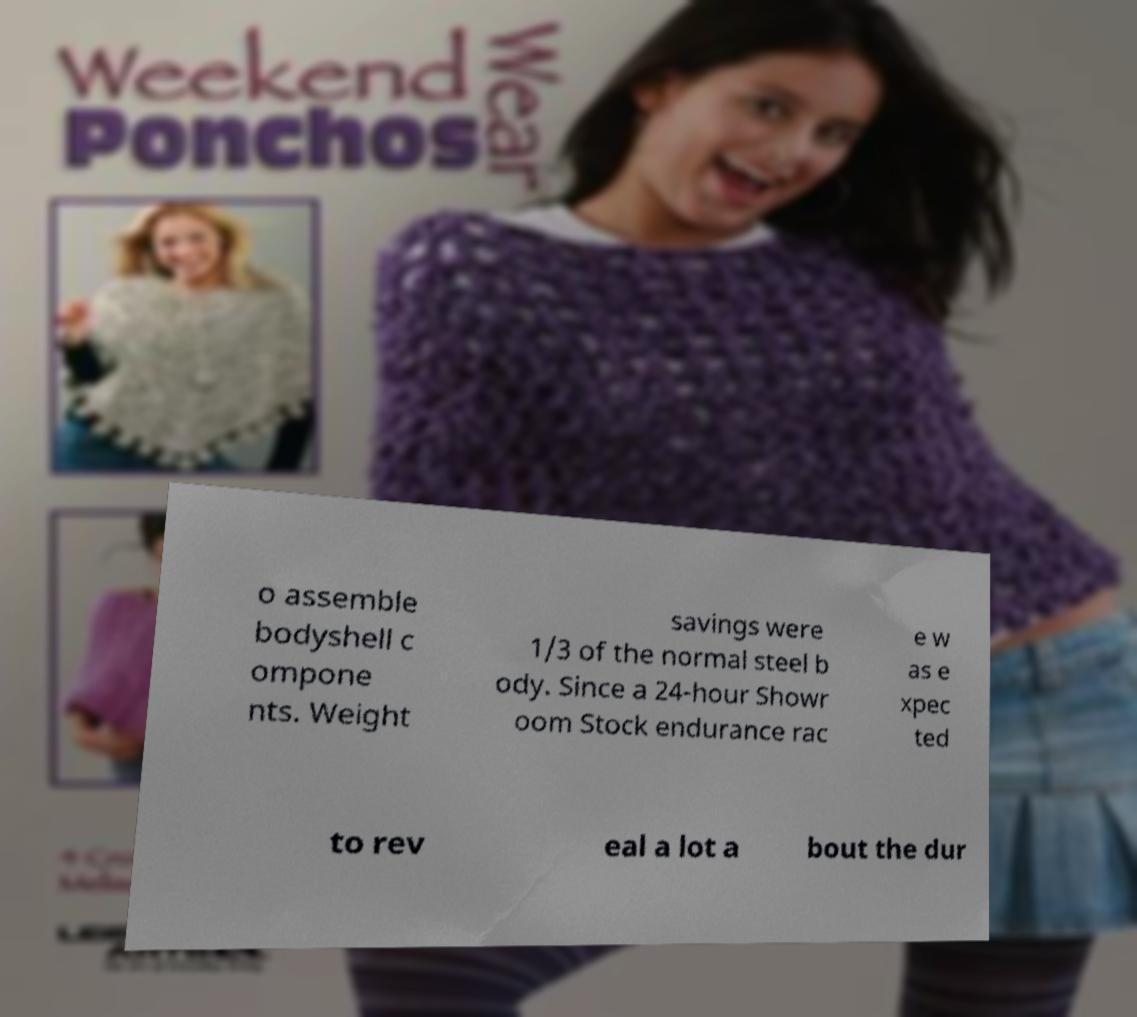For documentation purposes, I need the text within this image transcribed. Could you provide that? o assemble bodyshell c ompone nts. Weight savings were 1/3 of the normal steel b ody. Since a 24-hour Showr oom Stock endurance rac e w as e xpec ted to rev eal a lot a bout the dur 